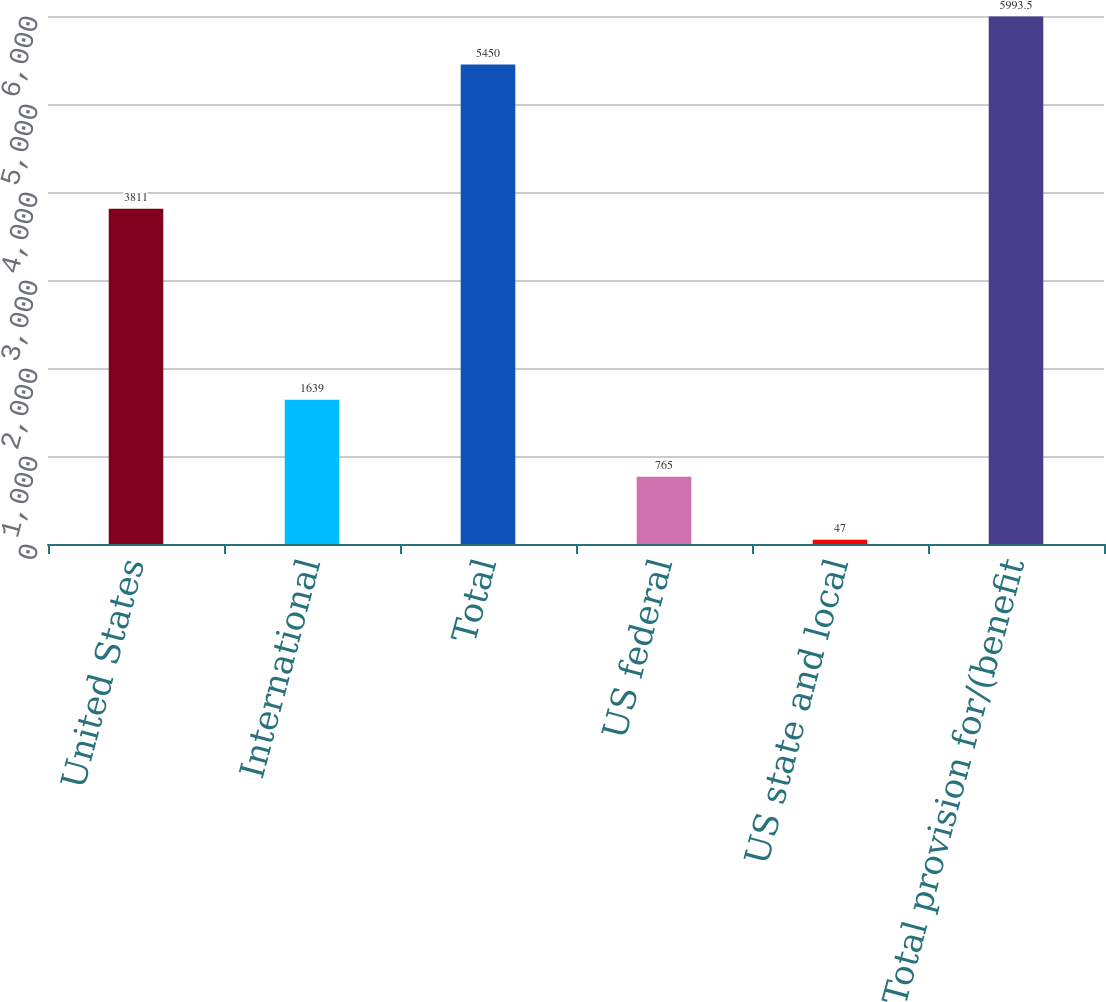Convert chart to OTSL. <chart><loc_0><loc_0><loc_500><loc_500><bar_chart><fcel>United States<fcel>International<fcel>Total<fcel>US federal<fcel>US state and local<fcel>Total provision for/(benefit<nl><fcel>3811<fcel>1639<fcel>5450<fcel>765<fcel>47<fcel>5993.5<nl></chart> 